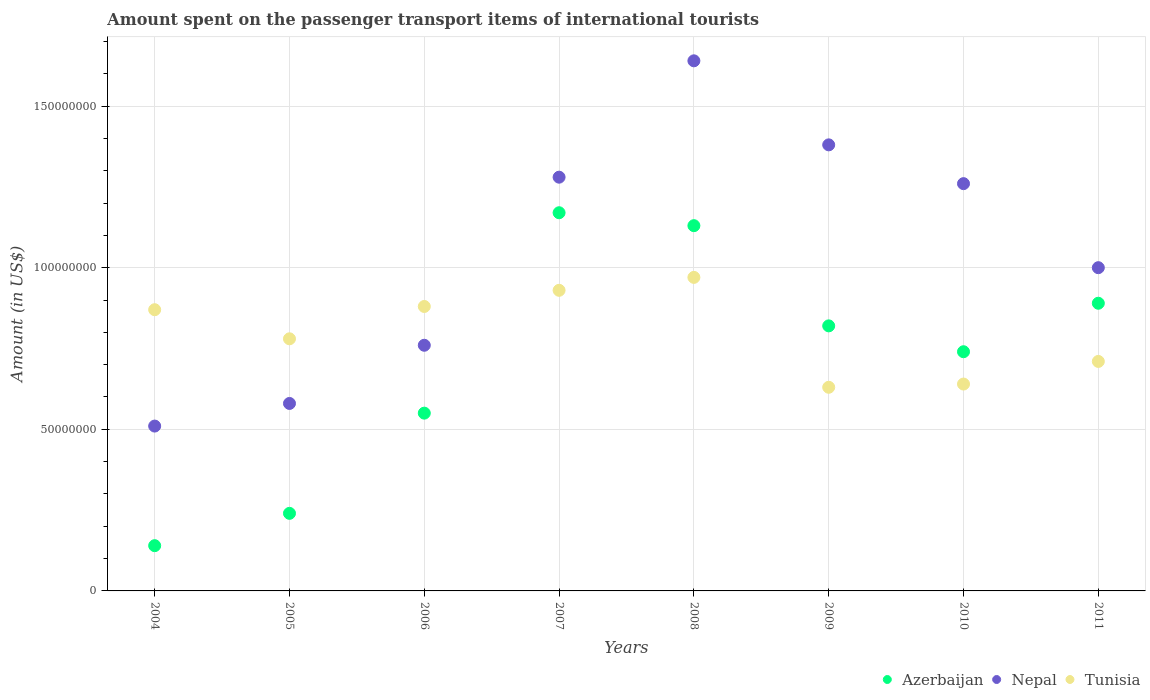What is the amount spent on the passenger transport items of international tourists in Nepal in 2009?
Your answer should be very brief. 1.38e+08. Across all years, what is the maximum amount spent on the passenger transport items of international tourists in Nepal?
Provide a succinct answer. 1.64e+08. Across all years, what is the minimum amount spent on the passenger transport items of international tourists in Azerbaijan?
Keep it short and to the point. 1.40e+07. What is the total amount spent on the passenger transport items of international tourists in Tunisia in the graph?
Provide a short and direct response. 6.41e+08. What is the difference between the amount spent on the passenger transport items of international tourists in Azerbaijan in 2007 and that in 2010?
Your answer should be compact. 4.30e+07. What is the difference between the amount spent on the passenger transport items of international tourists in Nepal in 2009 and the amount spent on the passenger transport items of international tourists in Azerbaijan in 2007?
Keep it short and to the point. 2.10e+07. What is the average amount spent on the passenger transport items of international tourists in Azerbaijan per year?
Your response must be concise. 7.10e+07. In the year 2004, what is the difference between the amount spent on the passenger transport items of international tourists in Nepal and amount spent on the passenger transport items of international tourists in Azerbaijan?
Your answer should be very brief. 3.70e+07. In how many years, is the amount spent on the passenger transport items of international tourists in Tunisia greater than 160000000 US$?
Ensure brevity in your answer.  0. What is the ratio of the amount spent on the passenger transport items of international tourists in Tunisia in 2007 to that in 2009?
Provide a succinct answer. 1.48. Is the amount spent on the passenger transport items of international tourists in Tunisia in 2007 less than that in 2010?
Offer a terse response. No. Is the difference between the amount spent on the passenger transport items of international tourists in Nepal in 2005 and 2008 greater than the difference between the amount spent on the passenger transport items of international tourists in Azerbaijan in 2005 and 2008?
Offer a very short reply. No. What is the difference between the highest and the second highest amount spent on the passenger transport items of international tourists in Tunisia?
Offer a terse response. 4.00e+06. What is the difference between the highest and the lowest amount spent on the passenger transport items of international tourists in Azerbaijan?
Keep it short and to the point. 1.03e+08. In how many years, is the amount spent on the passenger transport items of international tourists in Nepal greater than the average amount spent on the passenger transport items of international tourists in Nepal taken over all years?
Your answer should be compact. 4. Is the sum of the amount spent on the passenger transport items of international tourists in Tunisia in 2007 and 2010 greater than the maximum amount spent on the passenger transport items of international tourists in Azerbaijan across all years?
Provide a short and direct response. Yes. Is it the case that in every year, the sum of the amount spent on the passenger transport items of international tourists in Nepal and amount spent on the passenger transport items of international tourists in Azerbaijan  is greater than the amount spent on the passenger transport items of international tourists in Tunisia?
Ensure brevity in your answer.  No. Does the amount spent on the passenger transport items of international tourists in Azerbaijan monotonically increase over the years?
Provide a short and direct response. No. Is the amount spent on the passenger transport items of international tourists in Nepal strictly greater than the amount spent on the passenger transport items of international tourists in Azerbaijan over the years?
Make the answer very short. Yes. Is the amount spent on the passenger transport items of international tourists in Tunisia strictly less than the amount spent on the passenger transport items of international tourists in Azerbaijan over the years?
Give a very brief answer. No. How many years are there in the graph?
Ensure brevity in your answer.  8. Are the values on the major ticks of Y-axis written in scientific E-notation?
Keep it short and to the point. No. Does the graph contain grids?
Offer a very short reply. Yes. Where does the legend appear in the graph?
Offer a terse response. Bottom right. How many legend labels are there?
Offer a terse response. 3. How are the legend labels stacked?
Your response must be concise. Horizontal. What is the title of the graph?
Offer a terse response. Amount spent on the passenger transport items of international tourists. What is the Amount (in US$) in Azerbaijan in 2004?
Give a very brief answer. 1.40e+07. What is the Amount (in US$) of Nepal in 2004?
Your answer should be compact. 5.10e+07. What is the Amount (in US$) in Tunisia in 2004?
Offer a terse response. 8.70e+07. What is the Amount (in US$) in Azerbaijan in 2005?
Give a very brief answer. 2.40e+07. What is the Amount (in US$) of Nepal in 2005?
Provide a short and direct response. 5.80e+07. What is the Amount (in US$) in Tunisia in 2005?
Keep it short and to the point. 7.80e+07. What is the Amount (in US$) in Azerbaijan in 2006?
Provide a short and direct response. 5.50e+07. What is the Amount (in US$) in Nepal in 2006?
Your answer should be compact. 7.60e+07. What is the Amount (in US$) in Tunisia in 2006?
Keep it short and to the point. 8.80e+07. What is the Amount (in US$) of Azerbaijan in 2007?
Your response must be concise. 1.17e+08. What is the Amount (in US$) in Nepal in 2007?
Offer a terse response. 1.28e+08. What is the Amount (in US$) of Tunisia in 2007?
Ensure brevity in your answer.  9.30e+07. What is the Amount (in US$) of Azerbaijan in 2008?
Provide a succinct answer. 1.13e+08. What is the Amount (in US$) of Nepal in 2008?
Your answer should be compact. 1.64e+08. What is the Amount (in US$) of Tunisia in 2008?
Offer a very short reply. 9.70e+07. What is the Amount (in US$) in Azerbaijan in 2009?
Your answer should be very brief. 8.20e+07. What is the Amount (in US$) in Nepal in 2009?
Offer a terse response. 1.38e+08. What is the Amount (in US$) in Tunisia in 2009?
Offer a terse response. 6.30e+07. What is the Amount (in US$) in Azerbaijan in 2010?
Ensure brevity in your answer.  7.40e+07. What is the Amount (in US$) in Nepal in 2010?
Your answer should be very brief. 1.26e+08. What is the Amount (in US$) of Tunisia in 2010?
Make the answer very short. 6.40e+07. What is the Amount (in US$) of Azerbaijan in 2011?
Provide a short and direct response. 8.90e+07. What is the Amount (in US$) of Nepal in 2011?
Offer a very short reply. 1.00e+08. What is the Amount (in US$) of Tunisia in 2011?
Provide a succinct answer. 7.10e+07. Across all years, what is the maximum Amount (in US$) of Azerbaijan?
Provide a short and direct response. 1.17e+08. Across all years, what is the maximum Amount (in US$) in Nepal?
Offer a very short reply. 1.64e+08. Across all years, what is the maximum Amount (in US$) in Tunisia?
Give a very brief answer. 9.70e+07. Across all years, what is the minimum Amount (in US$) in Azerbaijan?
Your answer should be very brief. 1.40e+07. Across all years, what is the minimum Amount (in US$) in Nepal?
Provide a short and direct response. 5.10e+07. Across all years, what is the minimum Amount (in US$) of Tunisia?
Offer a very short reply. 6.30e+07. What is the total Amount (in US$) in Azerbaijan in the graph?
Provide a succinct answer. 5.68e+08. What is the total Amount (in US$) in Nepal in the graph?
Give a very brief answer. 8.41e+08. What is the total Amount (in US$) in Tunisia in the graph?
Make the answer very short. 6.41e+08. What is the difference between the Amount (in US$) in Azerbaijan in 2004 and that in 2005?
Ensure brevity in your answer.  -1.00e+07. What is the difference between the Amount (in US$) in Nepal in 2004 and that in 2005?
Your answer should be very brief. -7.00e+06. What is the difference between the Amount (in US$) of Tunisia in 2004 and that in 2005?
Your response must be concise. 9.00e+06. What is the difference between the Amount (in US$) in Azerbaijan in 2004 and that in 2006?
Provide a short and direct response. -4.10e+07. What is the difference between the Amount (in US$) of Nepal in 2004 and that in 2006?
Your response must be concise. -2.50e+07. What is the difference between the Amount (in US$) in Tunisia in 2004 and that in 2006?
Your answer should be compact. -1.00e+06. What is the difference between the Amount (in US$) in Azerbaijan in 2004 and that in 2007?
Offer a very short reply. -1.03e+08. What is the difference between the Amount (in US$) in Nepal in 2004 and that in 2007?
Offer a very short reply. -7.70e+07. What is the difference between the Amount (in US$) of Tunisia in 2004 and that in 2007?
Offer a very short reply. -6.00e+06. What is the difference between the Amount (in US$) of Azerbaijan in 2004 and that in 2008?
Provide a short and direct response. -9.90e+07. What is the difference between the Amount (in US$) of Nepal in 2004 and that in 2008?
Give a very brief answer. -1.13e+08. What is the difference between the Amount (in US$) in Tunisia in 2004 and that in 2008?
Offer a very short reply. -1.00e+07. What is the difference between the Amount (in US$) in Azerbaijan in 2004 and that in 2009?
Offer a terse response. -6.80e+07. What is the difference between the Amount (in US$) of Nepal in 2004 and that in 2009?
Your response must be concise. -8.70e+07. What is the difference between the Amount (in US$) in Tunisia in 2004 and that in 2009?
Keep it short and to the point. 2.40e+07. What is the difference between the Amount (in US$) in Azerbaijan in 2004 and that in 2010?
Give a very brief answer. -6.00e+07. What is the difference between the Amount (in US$) of Nepal in 2004 and that in 2010?
Keep it short and to the point. -7.50e+07. What is the difference between the Amount (in US$) in Tunisia in 2004 and that in 2010?
Your answer should be very brief. 2.30e+07. What is the difference between the Amount (in US$) in Azerbaijan in 2004 and that in 2011?
Offer a terse response. -7.50e+07. What is the difference between the Amount (in US$) in Nepal in 2004 and that in 2011?
Offer a very short reply. -4.90e+07. What is the difference between the Amount (in US$) of Tunisia in 2004 and that in 2011?
Give a very brief answer. 1.60e+07. What is the difference between the Amount (in US$) in Azerbaijan in 2005 and that in 2006?
Offer a terse response. -3.10e+07. What is the difference between the Amount (in US$) in Nepal in 2005 and that in 2006?
Your answer should be compact. -1.80e+07. What is the difference between the Amount (in US$) in Tunisia in 2005 and that in 2006?
Your response must be concise. -1.00e+07. What is the difference between the Amount (in US$) in Azerbaijan in 2005 and that in 2007?
Provide a succinct answer. -9.30e+07. What is the difference between the Amount (in US$) of Nepal in 2005 and that in 2007?
Keep it short and to the point. -7.00e+07. What is the difference between the Amount (in US$) of Tunisia in 2005 and that in 2007?
Your response must be concise. -1.50e+07. What is the difference between the Amount (in US$) in Azerbaijan in 2005 and that in 2008?
Make the answer very short. -8.90e+07. What is the difference between the Amount (in US$) in Nepal in 2005 and that in 2008?
Your answer should be very brief. -1.06e+08. What is the difference between the Amount (in US$) in Tunisia in 2005 and that in 2008?
Give a very brief answer. -1.90e+07. What is the difference between the Amount (in US$) of Azerbaijan in 2005 and that in 2009?
Make the answer very short. -5.80e+07. What is the difference between the Amount (in US$) in Nepal in 2005 and that in 2009?
Ensure brevity in your answer.  -8.00e+07. What is the difference between the Amount (in US$) in Tunisia in 2005 and that in 2009?
Your answer should be very brief. 1.50e+07. What is the difference between the Amount (in US$) in Azerbaijan in 2005 and that in 2010?
Your answer should be very brief. -5.00e+07. What is the difference between the Amount (in US$) in Nepal in 2005 and that in 2010?
Your answer should be compact. -6.80e+07. What is the difference between the Amount (in US$) in Tunisia in 2005 and that in 2010?
Keep it short and to the point. 1.40e+07. What is the difference between the Amount (in US$) in Azerbaijan in 2005 and that in 2011?
Keep it short and to the point. -6.50e+07. What is the difference between the Amount (in US$) in Nepal in 2005 and that in 2011?
Your answer should be very brief. -4.20e+07. What is the difference between the Amount (in US$) of Azerbaijan in 2006 and that in 2007?
Your response must be concise. -6.20e+07. What is the difference between the Amount (in US$) in Nepal in 2006 and that in 2007?
Offer a terse response. -5.20e+07. What is the difference between the Amount (in US$) in Tunisia in 2006 and that in 2007?
Ensure brevity in your answer.  -5.00e+06. What is the difference between the Amount (in US$) of Azerbaijan in 2006 and that in 2008?
Provide a short and direct response. -5.80e+07. What is the difference between the Amount (in US$) in Nepal in 2006 and that in 2008?
Ensure brevity in your answer.  -8.80e+07. What is the difference between the Amount (in US$) of Tunisia in 2006 and that in 2008?
Give a very brief answer. -9.00e+06. What is the difference between the Amount (in US$) in Azerbaijan in 2006 and that in 2009?
Provide a succinct answer. -2.70e+07. What is the difference between the Amount (in US$) of Nepal in 2006 and that in 2009?
Your response must be concise. -6.20e+07. What is the difference between the Amount (in US$) in Tunisia in 2006 and that in 2009?
Your answer should be compact. 2.50e+07. What is the difference between the Amount (in US$) in Azerbaijan in 2006 and that in 2010?
Give a very brief answer. -1.90e+07. What is the difference between the Amount (in US$) of Nepal in 2006 and that in 2010?
Provide a succinct answer. -5.00e+07. What is the difference between the Amount (in US$) in Tunisia in 2006 and that in 2010?
Give a very brief answer. 2.40e+07. What is the difference between the Amount (in US$) in Azerbaijan in 2006 and that in 2011?
Keep it short and to the point. -3.40e+07. What is the difference between the Amount (in US$) of Nepal in 2006 and that in 2011?
Provide a short and direct response. -2.40e+07. What is the difference between the Amount (in US$) of Tunisia in 2006 and that in 2011?
Keep it short and to the point. 1.70e+07. What is the difference between the Amount (in US$) in Nepal in 2007 and that in 2008?
Ensure brevity in your answer.  -3.60e+07. What is the difference between the Amount (in US$) in Tunisia in 2007 and that in 2008?
Your answer should be very brief. -4.00e+06. What is the difference between the Amount (in US$) of Azerbaijan in 2007 and that in 2009?
Offer a terse response. 3.50e+07. What is the difference between the Amount (in US$) in Nepal in 2007 and that in 2009?
Offer a very short reply. -1.00e+07. What is the difference between the Amount (in US$) in Tunisia in 2007 and that in 2009?
Make the answer very short. 3.00e+07. What is the difference between the Amount (in US$) in Azerbaijan in 2007 and that in 2010?
Your response must be concise. 4.30e+07. What is the difference between the Amount (in US$) of Tunisia in 2007 and that in 2010?
Provide a succinct answer. 2.90e+07. What is the difference between the Amount (in US$) in Azerbaijan in 2007 and that in 2011?
Your answer should be compact. 2.80e+07. What is the difference between the Amount (in US$) of Nepal in 2007 and that in 2011?
Your answer should be very brief. 2.80e+07. What is the difference between the Amount (in US$) in Tunisia in 2007 and that in 2011?
Ensure brevity in your answer.  2.20e+07. What is the difference between the Amount (in US$) of Azerbaijan in 2008 and that in 2009?
Make the answer very short. 3.10e+07. What is the difference between the Amount (in US$) in Nepal in 2008 and that in 2009?
Offer a very short reply. 2.60e+07. What is the difference between the Amount (in US$) in Tunisia in 2008 and that in 2009?
Ensure brevity in your answer.  3.40e+07. What is the difference between the Amount (in US$) of Azerbaijan in 2008 and that in 2010?
Keep it short and to the point. 3.90e+07. What is the difference between the Amount (in US$) in Nepal in 2008 and that in 2010?
Offer a terse response. 3.80e+07. What is the difference between the Amount (in US$) of Tunisia in 2008 and that in 2010?
Keep it short and to the point. 3.30e+07. What is the difference between the Amount (in US$) of Azerbaijan in 2008 and that in 2011?
Give a very brief answer. 2.40e+07. What is the difference between the Amount (in US$) of Nepal in 2008 and that in 2011?
Offer a very short reply. 6.40e+07. What is the difference between the Amount (in US$) of Tunisia in 2008 and that in 2011?
Make the answer very short. 2.60e+07. What is the difference between the Amount (in US$) in Azerbaijan in 2009 and that in 2010?
Ensure brevity in your answer.  8.00e+06. What is the difference between the Amount (in US$) in Tunisia in 2009 and that in 2010?
Offer a terse response. -1.00e+06. What is the difference between the Amount (in US$) of Azerbaijan in 2009 and that in 2011?
Offer a very short reply. -7.00e+06. What is the difference between the Amount (in US$) in Nepal in 2009 and that in 2011?
Ensure brevity in your answer.  3.80e+07. What is the difference between the Amount (in US$) of Tunisia in 2009 and that in 2011?
Ensure brevity in your answer.  -8.00e+06. What is the difference between the Amount (in US$) in Azerbaijan in 2010 and that in 2011?
Your answer should be compact. -1.50e+07. What is the difference between the Amount (in US$) of Nepal in 2010 and that in 2011?
Offer a terse response. 2.60e+07. What is the difference between the Amount (in US$) of Tunisia in 2010 and that in 2011?
Provide a succinct answer. -7.00e+06. What is the difference between the Amount (in US$) of Azerbaijan in 2004 and the Amount (in US$) of Nepal in 2005?
Make the answer very short. -4.40e+07. What is the difference between the Amount (in US$) of Azerbaijan in 2004 and the Amount (in US$) of Tunisia in 2005?
Offer a terse response. -6.40e+07. What is the difference between the Amount (in US$) in Nepal in 2004 and the Amount (in US$) in Tunisia in 2005?
Your answer should be compact. -2.70e+07. What is the difference between the Amount (in US$) of Azerbaijan in 2004 and the Amount (in US$) of Nepal in 2006?
Provide a succinct answer. -6.20e+07. What is the difference between the Amount (in US$) in Azerbaijan in 2004 and the Amount (in US$) in Tunisia in 2006?
Provide a succinct answer. -7.40e+07. What is the difference between the Amount (in US$) of Nepal in 2004 and the Amount (in US$) of Tunisia in 2006?
Your response must be concise. -3.70e+07. What is the difference between the Amount (in US$) in Azerbaijan in 2004 and the Amount (in US$) in Nepal in 2007?
Keep it short and to the point. -1.14e+08. What is the difference between the Amount (in US$) in Azerbaijan in 2004 and the Amount (in US$) in Tunisia in 2007?
Make the answer very short. -7.90e+07. What is the difference between the Amount (in US$) of Nepal in 2004 and the Amount (in US$) of Tunisia in 2007?
Provide a short and direct response. -4.20e+07. What is the difference between the Amount (in US$) of Azerbaijan in 2004 and the Amount (in US$) of Nepal in 2008?
Your response must be concise. -1.50e+08. What is the difference between the Amount (in US$) of Azerbaijan in 2004 and the Amount (in US$) of Tunisia in 2008?
Keep it short and to the point. -8.30e+07. What is the difference between the Amount (in US$) in Nepal in 2004 and the Amount (in US$) in Tunisia in 2008?
Give a very brief answer. -4.60e+07. What is the difference between the Amount (in US$) of Azerbaijan in 2004 and the Amount (in US$) of Nepal in 2009?
Provide a succinct answer. -1.24e+08. What is the difference between the Amount (in US$) of Azerbaijan in 2004 and the Amount (in US$) of Tunisia in 2009?
Your response must be concise. -4.90e+07. What is the difference between the Amount (in US$) of Nepal in 2004 and the Amount (in US$) of Tunisia in 2009?
Ensure brevity in your answer.  -1.20e+07. What is the difference between the Amount (in US$) of Azerbaijan in 2004 and the Amount (in US$) of Nepal in 2010?
Your response must be concise. -1.12e+08. What is the difference between the Amount (in US$) of Azerbaijan in 2004 and the Amount (in US$) of Tunisia in 2010?
Provide a short and direct response. -5.00e+07. What is the difference between the Amount (in US$) of Nepal in 2004 and the Amount (in US$) of Tunisia in 2010?
Provide a short and direct response. -1.30e+07. What is the difference between the Amount (in US$) in Azerbaijan in 2004 and the Amount (in US$) in Nepal in 2011?
Give a very brief answer. -8.60e+07. What is the difference between the Amount (in US$) in Azerbaijan in 2004 and the Amount (in US$) in Tunisia in 2011?
Make the answer very short. -5.70e+07. What is the difference between the Amount (in US$) of Nepal in 2004 and the Amount (in US$) of Tunisia in 2011?
Give a very brief answer. -2.00e+07. What is the difference between the Amount (in US$) in Azerbaijan in 2005 and the Amount (in US$) in Nepal in 2006?
Offer a very short reply. -5.20e+07. What is the difference between the Amount (in US$) of Azerbaijan in 2005 and the Amount (in US$) of Tunisia in 2006?
Your response must be concise. -6.40e+07. What is the difference between the Amount (in US$) of Nepal in 2005 and the Amount (in US$) of Tunisia in 2006?
Your answer should be very brief. -3.00e+07. What is the difference between the Amount (in US$) in Azerbaijan in 2005 and the Amount (in US$) in Nepal in 2007?
Your answer should be compact. -1.04e+08. What is the difference between the Amount (in US$) of Azerbaijan in 2005 and the Amount (in US$) of Tunisia in 2007?
Provide a succinct answer. -6.90e+07. What is the difference between the Amount (in US$) of Nepal in 2005 and the Amount (in US$) of Tunisia in 2007?
Keep it short and to the point. -3.50e+07. What is the difference between the Amount (in US$) of Azerbaijan in 2005 and the Amount (in US$) of Nepal in 2008?
Give a very brief answer. -1.40e+08. What is the difference between the Amount (in US$) in Azerbaijan in 2005 and the Amount (in US$) in Tunisia in 2008?
Your answer should be compact. -7.30e+07. What is the difference between the Amount (in US$) in Nepal in 2005 and the Amount (in US$) in Tunisia in 2008?
Give a very brief answer. -3.90e+07. What is the difference between the Amount (in US$) of Azerbaijan in 2005 and the Amount (in US$) of Nepal in 2009?
Make the answer very short. -1.14e+08. What is the difference between the Amount (in US$) of Azerbaijan in 2005 and the Amount (in US$) of Tunisia in 2009?
Provide a succinct answer. -3.90e+07. What is the difference between the Amount (in US$) of Nepal in 2005 and the Amount (in US$) of Tunisia in 2009?
Make the answer very short. -5.00e+06. What is the difference between the Amount (in US$) of Azerbaijan in 2005 and the Amount (in US$) of Nepal in 2010?
Offer a terse response. -1.02e+08. What is the difference between the Amount (in US$) of Azerbaijan in 2005 and the Amount (in US$) of Tunisia in 2010?
Offer a terse response. -4.00e+07. What is the difference between the Amount (in US$) in Nepal in 2005 and the Amount (in US$) in Tunisia in 2010?
Offer a terse response. -6.00e+06. What is the difference between the Amount (in US$) of Azerbaijan in 2005 and the Amount (in US$) of Nepal in 2011?
Your answer should be very brief. -7.60e+07. What is the difference between the Amount (in US$) in Azerbaijan in 2005 and the Amount (in US$) in Tunisia in 2011?
Provide a short and direct response. -4.70e+07. What is the difference between the Amount (in US$) of Nepal in 2005 and the Amount (in US$) of Tunisia in 2011?
Your response must be concise. -1.30e+07. What is the difference between the Amount (in US$) in Azerbaijan in 2006 and the Amount (in US$) in Nepal in 2007?
Give a very brief answer. -7.30e+07. What is the difference between the Amount (in US$) in Azerbaijan in 2006 and the Amount (in US$) in Tunisia in 2007?
Keep it short and to the point. -3.80e+07. What is the difference between the Amount (in US$) in Nepal in 2006 and the Amount (in US$) in Tunisia in 2007?
Offer a terse response. -1.70e+07. What is the difference between the Amount (in US$) in Azerbaijan in 2006 and the Amount (in US$) in Nepal in 2008?
Your response must be concise. -1.09e+08. What is the difference between the Amount (in US$) of Azerbaijan in 2006 and the Amount (in US$) of Tunisia in 2008?
Provide a short and direct response. -4.20e+07. What is the difference between the Amount (in US$) in Nepal in 2006 and the Amount (in US$) in Tunisia in 2008?
Ensure brevity in your answer.  -2.10e+07. What is the difference between the Amount (in US$) of Azerbaijan in 2006 and the Amount (in US$) of Nepal in 2009?
Your answer should be very brief. -8.30e+07. What is the difference between the Amount (in US$) of Azerbaijan in 2006 and the Amount (in US$) of Tunisia in 2009?
Your response must be concise. -8.00e+06. What is the difference between the Amount (in US$) of Nepal in 2006 and the Amount (in US$) of Tunisia in 2009?
Keep it short and to the point. 1.30e+07. What is the difference between the Amount (in US$) of Azerbaijan in 2006 and the Amount (in US$) of Nepal in 2010?
Offer a very short reply. -7.10e+07. What is the difference between the Amount (in US$) of Azerbaijan in 2006 and the Amount (in US$) of Tunisia in 2010?
Your answer should be compact. -9.00e+06. What is the difference between the Amount (in US$) in Azerbaijan in 2006 and the Amount (in US$) in Nepal in 2011?
Provide a succinct answer. -4.50e+07. What is the difference between the Amount (in US$) of Azerbaijan in 2006 and the Amount (in US$) of Tunisia in 2011?
Your response must be concise. -1.60e+07. What is the difference between the Amount (in US$) of Nepal in 2006 and the Amount (in US$) of Tunisia in 2011?
Provide a short and direct response. 5.00e+06. What is the difference between the Amount (in US$) in Azerbaijan in 2007 and the Amount (in US$) in Nepal in 2008?
Ensure brevity in your answer.  -4.70e+07. What is the difference between the Amount (in US$) of Azerbaijan in 2007 and the Amount (in US$) of Tunisia in 2008?
Offer a terse response. 2.00e+07. What is the difference between the Amount (in US$) of Nepal in 2007 and the Amount (in US$) of Tunisia in 2008?
Offer a very short reply. 3.10e+07. What is the difference between the Amount (in US$) of Azerbaijan in 2007 and the Amount (in US$) of Nepal in 2009?
Keep it short and to the point. -2.10e+07. What is the difference between the Amount (in US$) of Azerbaijan in 2007 and the Amount (in US$) of Tunisia in 2009?
Your answer should be compact. 5.40e+07. What is the difference between the Amount (in US$) of Nepal in 2007 and the Amount (in US$) of Tunisia in 2009?
Provide a succinct answer. 6.50e+07. What is the difference between the Amount (in US$) in Azerbaijan in 2007 and the Amount (in US$) in Nepal in 2010?
Give a very brief answer. -9.00e+06. What is the difference between the Amount (in US$) of Azerbaijan in 2007 and the Amount (in US$) of Tunisia in 2010?
Offer a very short reply. 5.30e+07. What is the difference between the Amount (in US$) of Nepal in 2007 and the Amount (in US$) of Tunisia in 2010?
Offer a very short reply. 6.40e+07. What is the difference between the Amount (in US$) of Azerbaijan in 2007 and the Amount (in US$) of Nepal in 2011?
Make the answer very short. 1.70e+07. What is the difference between the Amount (in US$) of Azerbaijan in 2007 and the Amount (in US$) of Tunisia in 2011?
Your response must be concise. 4.60e+07. What is the difference between the Amount (in US$) of Nepal in 2007 and the Amount (in US$) of Tunisia in 2011?
Keep it short and to the point. 5.70e+07. What is the difference between the Amount (in US$) in Azerbaijan in 2008 and the Amount (in US$) in Nepal in 2009?
Your answer should be compact. -2.50e+07. What is the difference between the Amount (in US$) in Nepal in 2008 and the Amount (in US$) in Tunisia in 2009?
Your answer should be compact. 1.01e+08. What is the difference between the Amount (in US$) of Azerbaijan in 2008 and the Amount (in US$) of Nepal in 2010?
Make the answer very short. -1.30e+07. What is the difference between the Amount (in US$) in Azerbaijan in 2008 and the Amount (in US$) in Tunisia in 2010?
Your response must be concise. 4.90e+07. What is the difference between the Amount (in US$) of Nepal in 2008 and the Amount (in US$) of Tunisia in 2010?
Make the answer very short. 1.00e+08. What is the difference between the Amount (in US$) of Azerbaijan in 2008 and the Amount (in US$) of Nepal in 2011?
Offer a very short reply. 1.30e+07. What is the difference between the Amount (in US$) of Azerbaijan in 2008 and the Amount (in US$) of Tunisia in 2011?
Provide a succinct answer. 4.20e+07. What is the difference between the Amount (in US$) of Nepal in 2008 and the Amount (in US$) of Tunisia in 2011?
Your answer should be very brief. 9.30e+07. What is the difference between the Amount (in US$) in Azerbaijan in 2009 and the Amount (in US$) in Nepal in 2010?
Keep it short and to the point. -4.40e+07. What is the difference between the Amount (in US$) of Azerbaijan in 2009 and the Amount (in US$) of Tunisia in 2010?
Provide a short and direct response. 1.80e+07. What is the difference between the Amount (in US$) in Nepal in 2009 and the Amount (in US$) in Tunisia in 2010?
Offer a very short reply. 7.40e+07. What is the difference between the Amount (in US$) in Azerbaijan in 2009 and the Amount (in US$) in Nepal in 2011?
Offer a very short reply. -1.80e+07. What is the difference between the Amount (in US$) of Azerbaijan in 2009 and the Amount (in US$) of Tunisia in 2011?
Give a very brief answer. 1.10e+07. What is the difference between the Amount (in US$) in Nepal in 2009 and the Amount (in US$) in Tunisia in 2011?
Give a very brief answer. 6.70e+07. What is the difference between the Amount (in US$) in Azerbaijan in 2010 and the Amount (in US$) in Nepal in 2011?
Your answer should be compact. -2.60e+07. What is the difference between the Amount (in US$) in Nepal in 2010 and the Amount (in US$) in Tunisia in 2011?
Offer a very short reply. 5.50e+07. What is the average Amount (in US$) of Azerbaijan per year?
Keep it short and to the point. 7.10e+07. What is the average Amount (in US$) in Nepal per year?
Provide a short and direct response. 1.05e+08. What is the average Amount (in US$) in Tunisia per year?
Offer a terse response. 8.01e+07. In the year 2004, what is the difference between the Amount (in US$) of Azerbaijan and Amount (in US$) of Nepal?
Make the answer very short. -3.70e+07. In the year 2004, what is the difference between the Amount (in US$) in Azerbaijan and Amount (in US$) in Tunisia?
Provide a succinct answer. -7.30e+07. In the year 2004, what is the difference between the Amount (in US$) in Nepal and Amount (in US$) in Tunisia?
Provide a short and direct response. -3.60e+07. In the year 2005, what is the difference between the Amount (in US$) in Azerbaijan and Amount (in US$) in Nepal?
Provide a succinct answer. -3.40e+07. In the year 2005, what is the difference between the Amount (in US$) in Azerbaijan and Amount (in US$) in Tunisia?
Your answer should be very brief. -5.40e+07. In the year 2005, what is the difference between the Amount (in US$) in Nepal and Amount (in US$) in Tunisia?
Offer a very short reply. -2.00e+07. In the year 2006, what is the difference between the Amount (in US$) in Azerbaijan and Amount (in US$) in Nepal?
Provide a short and direct response. -2.10e+07. In the year 2006, what is the difference between the Amount (in US$) of Azerbaijan and Amount (in US$) of Tunisia?
Your answer should be compact. -3.30e+07. In the year 2006, what is the difference between the Amount (in US$) in Nepal and Amount (in US$) in Tunisia?
Offer a very short reply. -1.20e+07. In the year 2007, what is the difference between the Amount (in US$) in Azerbaijan and Amount (in US$) in Nepal?
Make the answer very short. -1.10e+07. In the year 2007, what is the difference between the Amount (in US$) in Azerbaijan and Amount (in US$) in Tunisia?
Give a very brief answer. 2.40e+07. In the year 2007, what is the difference between the Amount (in US$) in Nepal and Amount (in US$) in Tunisia?
Your response must be concise. 3.50e+07. In the year 2008, what is the difference between the Amount (in US$) of Azerbaijan and Amount (in US$) of Nepal?
Your answer should be very brief. -5.10e+07. In the year 2008, what is the difference between the Amount (in US$) of Azerbaijan and Amount (in US$) of Tunisia?
Your answer should be compact. 1.60e+07. In the year 2008, what is the difference between the Amount (in US$) in Nepal and Amount (in US$) in Tunisia?
Ensure brevity in your answer.  6.70e+07. In the year 2009, what is the difference between the Amount (in US$) in Azerbaijan and Amount (in US$) in Nepal?
Provide a succinct answer. -5.60e+07. In the year 2009, what is the difference between the Amount (in US$) of Azerbaijan and Amount (in US$) of Tunisia?
Your answer should be very brief. 1.90e+07. In the year 2009, what is the difference between the Amount (in US$) in Nepal and Amount (in US$) in Tunisia?
Your response must be concise. 7.50e+07. In the year 2010, what is the difference between the Amount (in US$) of Azerbaijan and Amount (in US$) of Nepal?
Keep it short and to the point. -5.20e+07. In the year 2010, what is the difference between the Amount (in US$) in Azerbaijan and Amount (in US$) in Tunisia?
Your answer should be very brief. 1.00e+07. In the year 2010, what is the difference between the Amount (in US$) in Nepal and Amount (in US$) in Tunisia?
Provide a short and direct response. 6.20e+07. In the year 2011, what is the difference between the Amount (in US$) of Azerbaijan and Amount (in US$) of Nepal?
Offer a very short reply. -1.10e+07. In the year 2011, what is the difference between the Amount (in US$) of Azerbaijan and Amount (in US$) of Tunisia?
Offer a terse response. 1.80e+07. In the year 2011, what is the difference between the Amount (in US$) of Nepal and Amount (in US$) of Tunisia?
Your answer should be very brief. 2.90e+07. What is the ratio of the Amount (in US$) in Azerbaijan in 2004 to that in 2005?
Keep it short and to the point. 0.58. What is the ratio of the Amount (in US$) in Nepal in 2004 to that in 2005?
Keep it short and to the point. 0.88. What is the ratio of the Amount (in US$) in Tunisia in 2004 to that in 2005?
Your answer should be compact. 1.12. What is the ratio of the Amount (in US$) of Azerbaijan in 2004 to that in 2006?
Your answer should be compact. 0.25. What is the ratio of the Amount (in US$) of Nepal in 2004 to that in 2006?
Offer a very short reply. 0.67. What is the ratio of the Amount (in US$) in Azerbaijan in 2004 to that in 2007?
Make the answer very short. 0.12. What is the ratio of the Amount (in US$) in Nepal in 2004 to that in 2007?
Your answer should be very brief. 0.4. What is the ratio of the Amount (in US$) in Tunisia in 2004 to that in 2007?
Offer a terse response. 0.94. What is the ratio of the Amount (in US$) of Azerbaijan in 2004 to that in 2008?
Your answer should be compact. 0.12. What is the ratio of the Amount (in US$) of Nepal in 2004 to that in 2008?
Provide a short and direct response. 0.31. What is the ratio of the Amount (in US$) in Tunisia in 2004 to that in 2008?
Give a very brief answer. 0.9. What is the ratio of the Amount (in US$) in Azerbaijan in 2004 to that in 2009?
Give a very brief answer. 0.17. What is the ratio of the Amount (in US$) of Nepal in 2004 to that in 2009?
Give a very brief answer. 0.37. What is the ratio of the Amount (in US$) of Tunisia in 2004 to that in 2009?
Offer a very short reply. 1.38. What is the ratio of the Amount (in US$) of Azerbaijan in 2004 to that in 2010?
Your answer should be very brief. 0.19. What is the ratio of the Amount (in US$) in Nepal in 2004 to that in 2010?
Your response must be concise. 0.4. What is the ratio of the Amount (in US$) of Tunisia in 2004 to that in 2010?
Ensure brevity in your answer.  1.36. What is the ratio of the Amount (in US$) of Azerbaijan in 2004 to that in 2011?
Provide a succinct answer. 0.16. What is the ratio of the Amount (in US$) in Nepal in 2004 to that in 2011?
Offer a very short reply. 0.51. What is the ratio of the Amount (in US$) of Tunisia in 2004 to that in 2011?
Your answer should be very brief. 1.23. What is the ratio of the Amount (in US$) of Azerbaijan in 2005 to that in 2006?
Ensure brevity in your answer.  0.44. What is the ratio of the Amount (in US$) in Nepal in 2005 to that in 2006?
Your answer should be compact. 0.76. What is the ratio of the Amount (in US$) in Tunisia in 2005 to that in 2006?
Provide a succinct answer. 0.89. What is the ratio of the Amount (in US$) of Azerbaijan in 2005 to that in 2007?
Make the answer very short. 0.21. What is the ratio of the Amount (in US$) in Nepal in 2005 to that in 2007?
Your response must be concise. 0.45. What is the ratio of the Amount (in US$) in Tunisia in 2005 to that in 2007?
Make the answer very short. 0.84. What is the ratio of the Amount (in US$) of Azerbaijan in 2005 to that in 2008?
Your answer should be very brief. 0.21. What is the ratio of the Amount (in US$) in Nepal in 2005 to that in 2008?
Your answer should be compact. 0.35. What is the ratio of the Amount (in US$) in Tunisia in 2005 to that in 2008?
Keep it short and to the point. 0.8. What is the ratio of the Amount (in US$) in Azerbaijan in 2005 to that in 2009?
Your answer should be very brief. 0.29. What is the ratio of the Amount (in US$) in Nepal in 2005 to that in 2009?
Offer a terse response. 0.42. What is the ratio of the Amount (in US$) in Tunisia in 2005 to that in 2009?
Offer a very short reply. 1.24. What is the ratio of the Amount (in US$) of Azerbaijan in 2005 to that in 2010?
Offer a very short reply. 0.32. What is the ratio of the Amount (in US$) of Nepal in 2005 to that in 2010?
Give a very brief answer. 0.46. What is the ratio of the Amount (in US$) of Tunisia in 2005 to that in 2010?
Give a very brief answer. 1.22. What is the ratio of the Amount (in US$) in Azerbaijan in 2005 to that in 2011?
Keep it short and to the point. 0.27. What is the ratio of the Amount (in US$) of Nepal in 2005 to that in 2011?
Provide a short and direct response. 0.58. What is the ratio of the Amount (in US$) of Tunisia in 2005 to that in 2011?
Provide a succinct answer. 1.1. What is the ratio of the Amount (in US$) in Azerbaijan in 2006 to that in 2007?
Your answer should be very brief. 0.47. What is the ratio of the Amount (in US$) of Nepal in 2006 to that in 2007?
Keep it short and to the point. 0.59. What is the ratio of the Amount (in US$) in Tunisia in 2006 to that in 2007?
Give a very brief answer. 0.95. What is the ratio of the Amount (in US$) of Azerbaijan in 2006 to that in 2008?
Make the answer very short. 0.49. What is the ratio of the Amount (in US$) in Nepal in 2006 to that in 2008?
Offer a terse response. 0.46. What is the ratio of the Amount (in US$) in Tunisia in 2006 to that in 2008?
Provide a short and direct response. 0.91. What is the ratio of the Amount (in US$) in Azerbaijan in 2006 to that in 2009?
Provide a succinct answer. 0.67. What is the ratio of the Amount (in US$) in Nepal in 2006 to that in 2009?
Your answer should be compact. 0.55. What is the ratio of the Amount (in US$) of Tunisia in 2006 to that in 2009?
Your response must be concise. 1.4. What is the ratio of the Amount (in US$) in Azerbaijan in 2006 to that in 2010?
Offer a terse response. 0.74. What is the ratio of the Amount (in US$) of Nepal in 2006 to that in 2010?
Ensure brevity in your answer.  0.6. What is the ratio of the Amount (in US$) of Tunisia in 2006 to that in 2010?
Provide a succinct answer. 1.38. What is the ratio of the Amount (in US$) in Azerbaijan in 2006 to that in 2011?
Provide a short and direct response. 0.62. What is the ratio of the Amount (in US$) of Nepal in 2006 to that in 2011?
Offer a very short reply. 0.76. What is the ratio of the Amount (in US$) of Tunisia in 2006 to that in 2011?
Ensure brevity in your answer.  1.24. What is the ratio of the Amount (in US$) in Azerbaijan in 2007 to that in 2008?
Your answer should be compact. 1.04. What is the ratio of the Amount (in US$) in Nepal in 2007 to that in 2008?
Give a very brief answer. 0.78. What is the ratio of the Amount (in US$) in Tunisia in 2007 to that in 2008?
Offer a very short reply. 0.96. What is the ratio of the Amount (in US$) of Azerbaijan in 2007 to that in 2009?
Offer a very short reply. 1.43. What is the ratio of the Amount (in US$) in Nepal in 2007 to that in 2009?
Make the answer very short. 0.93. What is the ratio of the Amount (in US$) in Tunisia in 2007 to that in 2009?
Your answer should be very brief. 1.48. What is the ratio of the Amount (in US$) in Azerbaijan in 2007 to that in 2010?
Offer a very short reply. 1.58. What is the ratio of the Amount (in US$) in Nepal in 2007 to that in 2010?
Offer a terse response. 1.02. What is the ratio of the Amount (in US$) of Tunisia in 2007 to that in 2010?
Make the answer very short. 1.45. What is the ratio of the Amount (in US$) in Azerbaijan in 2007 to that in 2011?
Keep it short and to the point. 1.31. What is the ratio of the Amount (in US$) in Nepal in 2007 to that in 2011?
Make the answer very short. 1.28. What is the ratio of the Amount (in US$) of Tunisia in 2007 to that in 2011?
Your answer should be compact. 1.31. What is the ratio of the Amount (in US$) of Azerbaijan in 2008 to that in 2009?
Offer a terse response. 1.38. What is the ratio of the Amount (in US$) of Nepal in 2008 to that in 2009?
Your response must be concise. 1.19. What is the ratio of the Amount (in US$) of Tunisia in 2008 to that in 2009?
Your answer should be compact. 1.54. What is the ratio of the Amount (in US$) in Azerbaijan in 2008 to that in 2010?
Give a very brief answer. 1.53. What is the ratio of the Amount (in US$) in Nepal in 2008 to that in 2010?
Ensure brevity in your answer.  1.3. What is the ratio of the Amount (in US$) of Tunisia in 2008 to that in 2010?
Make the answer very short. 1.52. What is the ratio of the Amount (in US$) of Azerbaijan in 2008 to that in 2011?
Give a very brief answer. 1.27. What is the ratio of the Amount (in US$) of Nepal in 2008 to that in 2011?
Give a very brief answer. 1.64. What is the ratio of the Amount (in US$) in Tunisia in 2008 to that in 2011?
Provide a short and direct response. 1.37. What is the ratio of the Amount (in US$) in Azerbaijan in 2009 to that in 2010?
Your response must be concise. 1.11. What is the ratio of the Amount (in US$) of Nepal in 2009 to that in 2010?
Your answer should be very brief. 1.1. What is the ratio of the Amount (in US$) in Tunisia in 2009 to that in 2010?
Give a very brief answer. 0.98. What is the ratio of the Amount (in US$) of Azerbaijan in 2009 to that in 2011?
Provide a short and direct response. 0.92. What is the ratio of the Amount (in US$) in Nepal in 2009 to that in 2011?
Provide a succinct answer. 1.38. What is the ratio of the Amount (in US$) of Tunisia in 2009 to that in 2011?
Offer a terse response. 0.89. What is the ratio of the Amount (in US$) of Azerbaijan in 2010 to that in 2011?
Offer a terse response. 0.83. What is the ratio of the Amount (in US$) in Nepal in 2010 to that in 2011?
Offer a very short reply. 1.26. What is the ratio of the Amount (in US$) in Tunisia in 2010 to that in 2011?
Keep it short and to the point. 0.9. What is the difference between the highest and the second highest Amount (in US$) of Azerbaijan?
Your response must be concise. 4.00e+06. What is the difference between the highest and the second highest Amount (in US$) in Nepal?
Provide a short and direct response. 2.60e+07. What is the difference between the highest and the lowest Amount (in US$) in Azerbaijan?
Your answer should be compact. 1.03e+08. What is the difference between the highest and the lowest Amount (in US$) in Nepal?
Your answer should be very brief. 1.13e+08. What is the difference between the highest and the lowest Amount (in US$) in Tunisia?
Your response must be concise. 3.40e+07. 